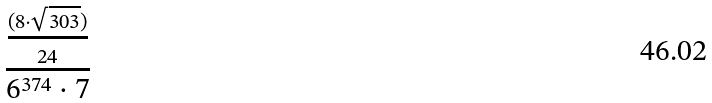<formula> <loc_0><loc_0><loc_500><loc_500>\frac { \frac { ( 8 \cdot \sqrt { 3 0 3 } ) } { 2 4 } } { 6 ^ { 3 7 4 } \cdot 7 }</formula> 